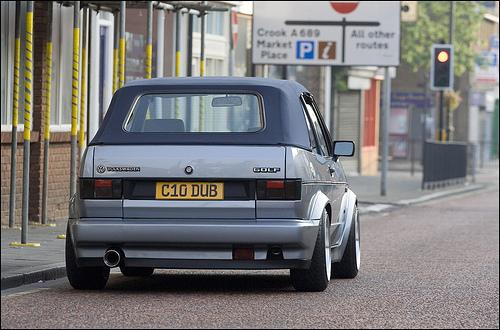What is the shape of the handrail near the curb, and what is its color? The handrail near the curb is a black metal railing, with a linear and nearly rectangular shape. What type of car is parked next to the curb and what is unique about its license plate? A light gray Volkswagen is parked next to the curb with a yellow and black license plate that reads "C10 DUB." What is on the sign in front of the car and what is the shape of the blue graphic? The white sign has a blue square with a white "P" inside, black words, and a brown and white "i" graphic. Describe the rear view and side view mirrors of the car. The rear view mirror is inside the car, and the side view mirror is on the car's right side, both with reflective surfaces. What can you see inside the car and where is it located? Inside the car, you can see the driver's seat headrest, which is located behind the blue convertible top. What color is the traffic light in the background and what is behind it? The traffic light in the background is red, with a tree in the background. What can be found near the traffic light, and what is the color of its bands? Near the traffic light, there are metal poles with yellow bands wrapped around them and a wrought iron barrier. Tell me about the traffic light and its surroundings. The traffic light in front of the car is red, mounted on a black pole with a gray shape around it, and there is a tree behind it. Describe one of the car's tires and its location. The rear tire on the right side of the car is black, circular, and located beside the car's right front tire. What type of pavement is the car parked on and what is near the road? The car is parked on a street paved with small stones, with a pavement and a fence made of metal poles nearby. What type of car is in the image? A grey car with a blue convertible top. What color is the license plate on the car in the image? Yellow and black. Identify and describe the location of the car in the image. The car is parked on the street near a curb. Is the driver standing outside the car trying to open the door with a key? This instruction is misleading because there is no driver visible outside the car in the image. One object has yellow tape around it, can you describe it? Metal poles on the sidewalk wrapped with yellow tape. Describe the overall background scenery displayed in the image. A tree behind a red traffic light, paved street, and a building with brick front. What is the color of the light on the traffic light in front of the car?  Red. Is there any moving object in the image? No, there are no moving objects. Do the license plates on the car have blue lettering? This instruction is misleading because the license plates on the car have orange lettering, not blue. Is the tree behind the traffic light a palm tree? This instruction is misleading because there is a tree behind the traffic light, but there is not enough information to determine if it is a palm tree or not. Can you create a short poem about the scene depicted in the image? Underneath the red eclipse, Which of the following details describes the railing in the image: wooden, metal, or made of rope?  Metal. What is the unusual feature about the license plate's text? It begins with the letter "c." Is the car parked next to the curb green? The instruction is misleading because the car parked next to the curb is light gray, not green. Are there pedestrians walking on the sidewalk near the poles wrapped with yellow tape? This instruction is misleading because there are no pedestrians visible in the image near the poles wrapped with yellow tape. Read the text on the large sign in the image. White and blue "P" and brown and white "I." What is the material that the street is paved with in the picture? Small stones. Is there a bicycle leaning against the black metal railing near the curb? This instruction is misleading because there is a black metal railing near the curb, but there is not a bicycle leaning against it in the image. Describe any activity or action performed by humans in the image. No human activities detected in the image. What brand does the image's car belong to? Volkswagen. Which action is the driver performing: parking or driving? Parking. What is the color of the pole where the traffic light is mounted? Black. What is the main event taking place in the image?  A car parked by the curb. 